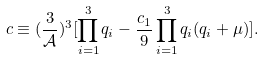Convert formula to latex. <formula><loc_0><loc_0><loc_500><loc_500>c \equiv ( \frac { 3 } { \mathcal { A } } ) ^ { 3 } [ \prod _ { i = 1 } ^ { 3 } q _ { i } - \frac { c _ { 1 } } { 9 } \prod _ { i = 1 } ^ { 3 } q _ { i } ( q _ { i } + \mu ) ] .</formula> 